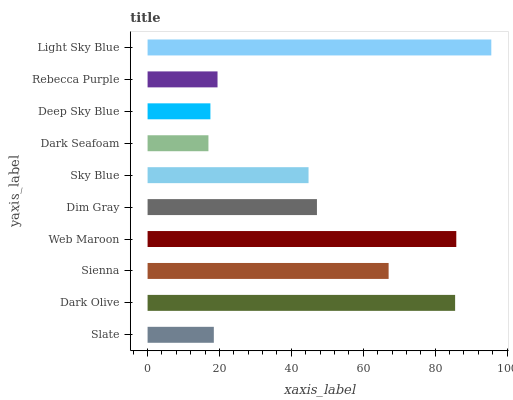Is Dark Seafoam the minimum?
Answer yes or no. Yes. Is Light Sky Blue the maximum?
Answer yes or no. Yes. Is Dark Olive the minimum?
Answer yes or no. No. Is Dark Olive the maximum?
Answer yes or no. No. Is Dark Olive greater than Slate?
Answer yes or no. Yes. Is Slate less than Dark Olive?
Answer yes or no. Yes. Is Slate greater than Dark Olive?
Answer yes or no. No. Is Dark Olive less than Slate?
Answer yes or no. No. Is Dim Gray the high median?
Answer yes or no. Yes. Is Sky Blue the low median?
Answer yes or no. Yes. Is Dark Olive the high median?
Answer yes or no. No. Is Dim Gray the low median?
Answer yes or no. No. 